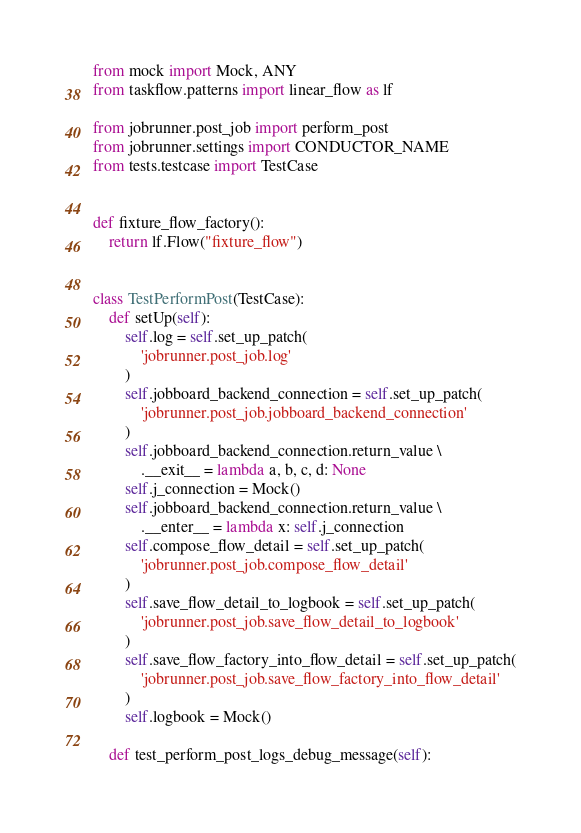<code> <loc_0><loc_0><loc_500><loc_500><_Python_>from mock import Mock, ANY
from taskflow.patterns import linear_flow as lf

from jobrunner.post_job import perform_post
from jobrunner.settings import CONDUCTOR_NAME
from tests.testcase import TestCase


def fixture_flow_factory():
    return lf.Flow("fixture_flow")


class TestPerformPost(TestCase):
    def setUp(self):
        self.log = self.set_up_patch(
            'jobrunner.post_job.log'
        )
        self.jobboard_backend_connection = self.set_up_patch(
            'jobrunner.post_job.jobboard_backend_connection'
        )
        self.jobboard_backend_connection.return_value \
            .__exit__ = lambda a, b, c, d: None
        self.j_connection = Mock()
        self.jobboard_backend_connection.return_value \
            .__enter__ = lambda x: self.j_connection
        self.compose_flow_detail = self.set_up_patch(
            'jobrunner.post_job.compose_flow_detail'
        )
        self.save_flow_detail_to_logbook = self.set_up_patch(
            'jobrunner.post_job.save_flow_detail_to_logbook'
        )
        self.save_flow_factory_into_flow_detail = self.set_up_patch(
            'jobrunner.post_job.save_flow_factory_into_flow_detail'
        )
        self.logbook = Mock()

    def test_perform_post_logs_debug_message(self):</code> 